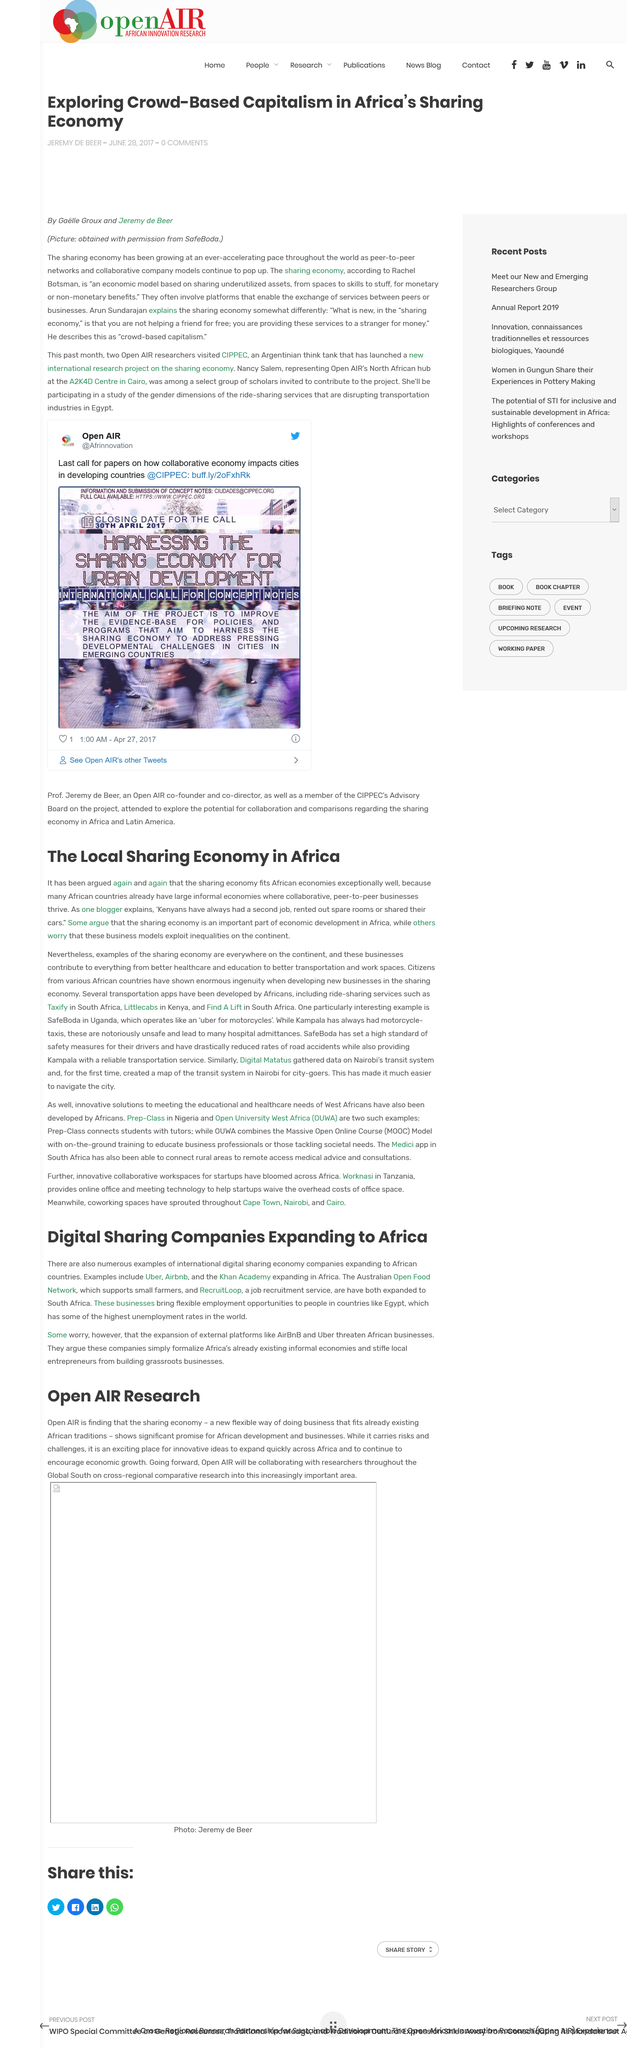Mention a couple of crucial points in this snapshot. Airbnb is an example of an international digital sharing economy company that has expanded to African countries. This article was published on June 28th, 2017, Kenyans commonly supplement their primary income by obtaining additional employment, renting out unused spaces, or utilizing their personal vehicles for profit. Gaelle Groux and Jeremy de Beer are the authors of this article. The sharing economy is well-suited to African economies because many African countries already have thriving informal economies where collaborative and peer-to-peer businesses are common. 